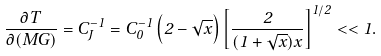<formula> <loc_0><loc_0><loc_500><loc_500>\frac { \partial T } { \partial ( M G ) } = C _ { J } ^ { - 1 } = C ^ { - 1 } _ { 0 } \left ( 2 - \sqrt { x } \right ) \left [ \frac { 2 } { ( 1 + \sqrt { x } ) x } \right ] ^ { 1 / 2 } < < 1 .</formula> 